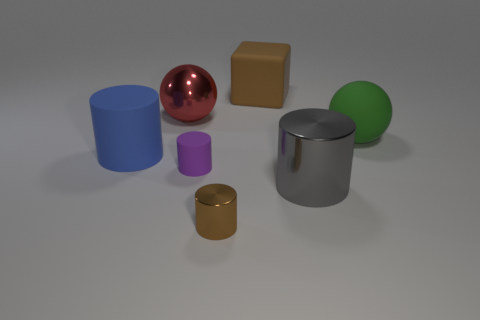Subtract 1 cylinders. How many cylinders are left? 3 Subtract all brown cylinders. How many cylinders are left? 3 Subtract all blue cylinders. How many cylinders are left? 3 Subtract all green cylinders. Subtract all red blocks. How many cylinders are left? 4 Add 1 metal spheres. How many objects exist? 8 Subtract all cylinders. How many objects are left? 3 Subtract all large gray cubes. Subtract all tiny purple things. How many objects are left? 6 Add 6 small purple rubber cylinders. How many small purple rubber cylinders are left? 7 Add 4 big green spheres. How many big green spheres exist? 5 Subtract 0 cyan balls. How many objects are left? 7 